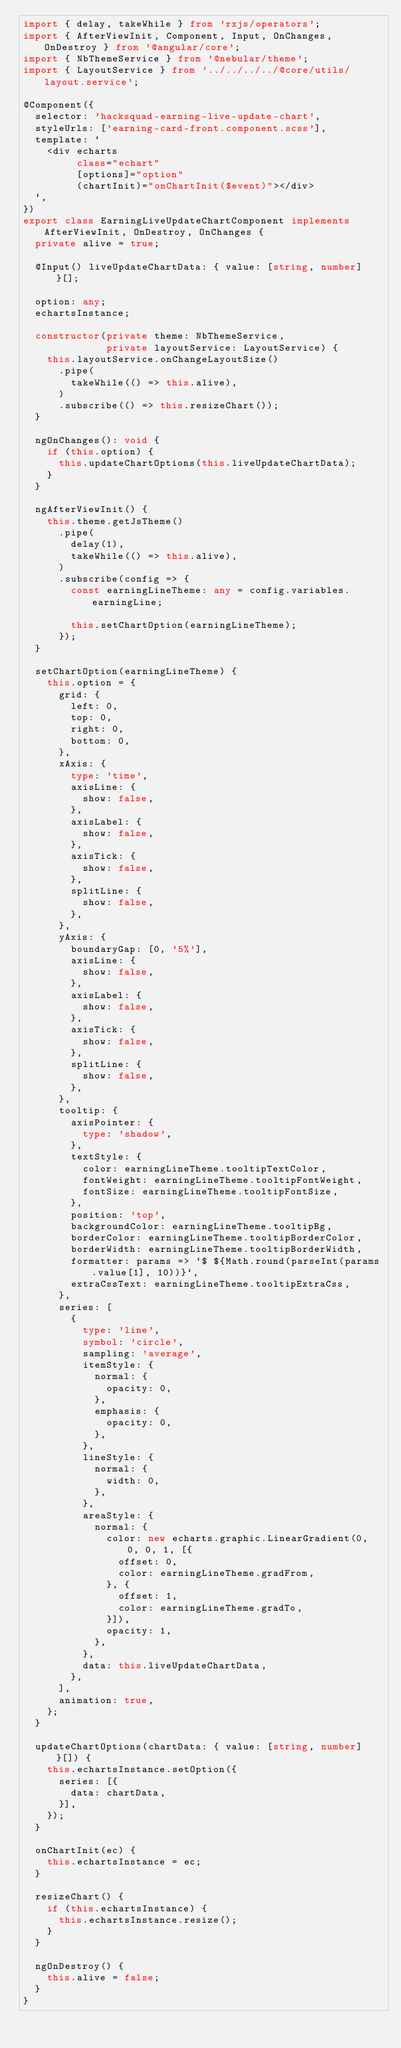<code> <loc_0><loc_0><loc_500><loc_500><_TypeScript_>import { delay, takeWhile } from 'rxjs/operators';
import { AfterViewInit, Component, Input, OnChanges, OnDestroy } from '@angular/core';
import { NbThemeService } from '@nebular/theme';
import { LayoutService } from '../../../../@core/utils/layout.service';

@Component({
  selector: 'hacksquad-earning-live-update-chart',
  styleUrls: ['earning-card-front.component.scss'],
  template: `
    <div echarts
         class="echart"
         [options]="option"
         (chartInit)="onChartInit($event)"></div>
  `,
})
export class EarningLiveUpdateChartComponent implements AfterViewInit, OnDestroy, OnChanges {
  private alive = true;

  @Input() liveUpdateChartData: { value: [string, number] }[];

  option: any;
  echartsInstance;

  constructor(private theme: NbThemeService,
              private layoutService: LayoutService) {
    this.layoutService.onChangeLayoutSize()
      .pipe(
        takeWhile(() => this.alive),
      )
      .subscribe(() => this.resizeChart());
  }

  ngOnChanges(): void {
    if (this.option) {
      this.updateChartOptions(this.liveUpdateChartData);
    }
  }

  ngAfterViewInit() {
    this.theme.getJsTheme()
      .pipe(
        delay(1),
        takeWhile(() => this.alive),
      )
      .subscribe(config => {
        const earningLineTheme: any = config.variables.earningLine;

        this.setChartOption(earningLineTheme);
      });
  }

  setChartOption(earningLineTheme) {
    this.option = {
      grid: {
        left: 0,
        top: 0,
        right: 0,
        bottom: 0,
      },
      xAxis: {
        type: 'time',
        axisLine: {
          show: false,
        },
        axisLabel: {
          show: false,
        },
        axisTick: {
          show: false,
        },
        splitLine: {
          show: false,
        },
      },
      yAxis: {
        boundaryGap: [0, '5%'],
        axisLine: {
          show: false,
        },
        axisLabel: {
          show: false,
        },
        axisTick: {
          show: false,
        },
        splitLine: {
          show: false,
        },
      },
      tooltip: {
        axisPointer: {
          type: 'shadow',
        },
        textStyle: {
          color: earningLineTheme.tooltipTextColor,
          fontWeight: earningLineTheme.tooltipFontWeight,
          fontSize: earningLineTheme.tooltipFontSize,
        },
        position: 'top',
        backgroundColor: earningLineTheme.tooltipBg,
        borderColor: earningLineTheme.tooltipBorderColor,
        borderWidth: earningLineTheme.tooltipBorderWidth,
        formatter: params => `$ ${Math.round(parseInt(params.value[1], 10))}`,
        extraCssText: earningLineTheme.tooltipExtraCss,
      },
      series: [
        {
          type: 'line',
          symbol: 'circle',
          sampling: 'average',
          itemStyle: {
            normal: {
              opacity: 0,
            },
            emphasis: {
              opacity: 0,
            },
          },
          lineStyle: {
            normal: {
              width: 0,
            },
          },
          areaStyle: {
            normal: {
              color: new echarts.graphic.LinearGradient(0, 0, 0, 1, [{
                offset: 0,
                color: earningLineTheme.gradFrom,
              }, {
                offset: 1,
                color: earningLineTheme.gradTo,
              }]),
              opacity: 1,
            },
          },
          data: this.liveUpdateChartData,
        },
      ],
      animation: true,
    };
  }

  updateChartOptions(chartData: { value: [string, number] }[]) {
    this.echartsInstance.setOption({
      series: [{
        data: chartData,
      }],
    });
  }

  onChartInit(ec) {
    this.echartsInstance = ec;
  }

  resizeChart() {
    if (this.echartsInstance) {
      this.echartsInstance.resize();
    }
  }

  ngOnDestroy() {
    this.alive = false;
  }
}
</code> 